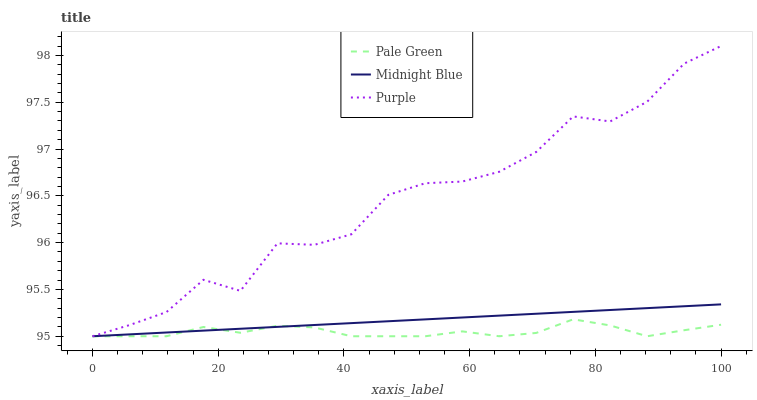Does Pale Green have the minimum area under the curve?
Answer yes or no. Yes. Does Purple have the maximum area under the curve?
Answer yes or no. Yes. Does Midnight Blue have the minimum area under the curve?
Answer yes or no. No. Does Midnight Blue have the maximum area under the curve?
Answer yes or no. No. Is Midnight Blue the smoothest?
Answer yes or no. Yes. Is Purple the roughest?
Answer yes or no. Yes. Is Pale Green the smoothest?
Answer yes or no. No. Is Pale Green the roughest?
Answer yes or no. No. Does Purple have the lowest value?
Answer yes or no. Yes. Does Purple have the highest value?
Answer yes or no. Yes. Does Midnight Blue have the highest value?
Answer yes or no. No. Does Pale Green intersect Midnight Blue?
Answer yes or no. Yes. Is Pale Green less than Midnight Blue?
Answer yes or no. No. Is Pale Green greater than Midnight Blue?
Answer yes or no. No. 